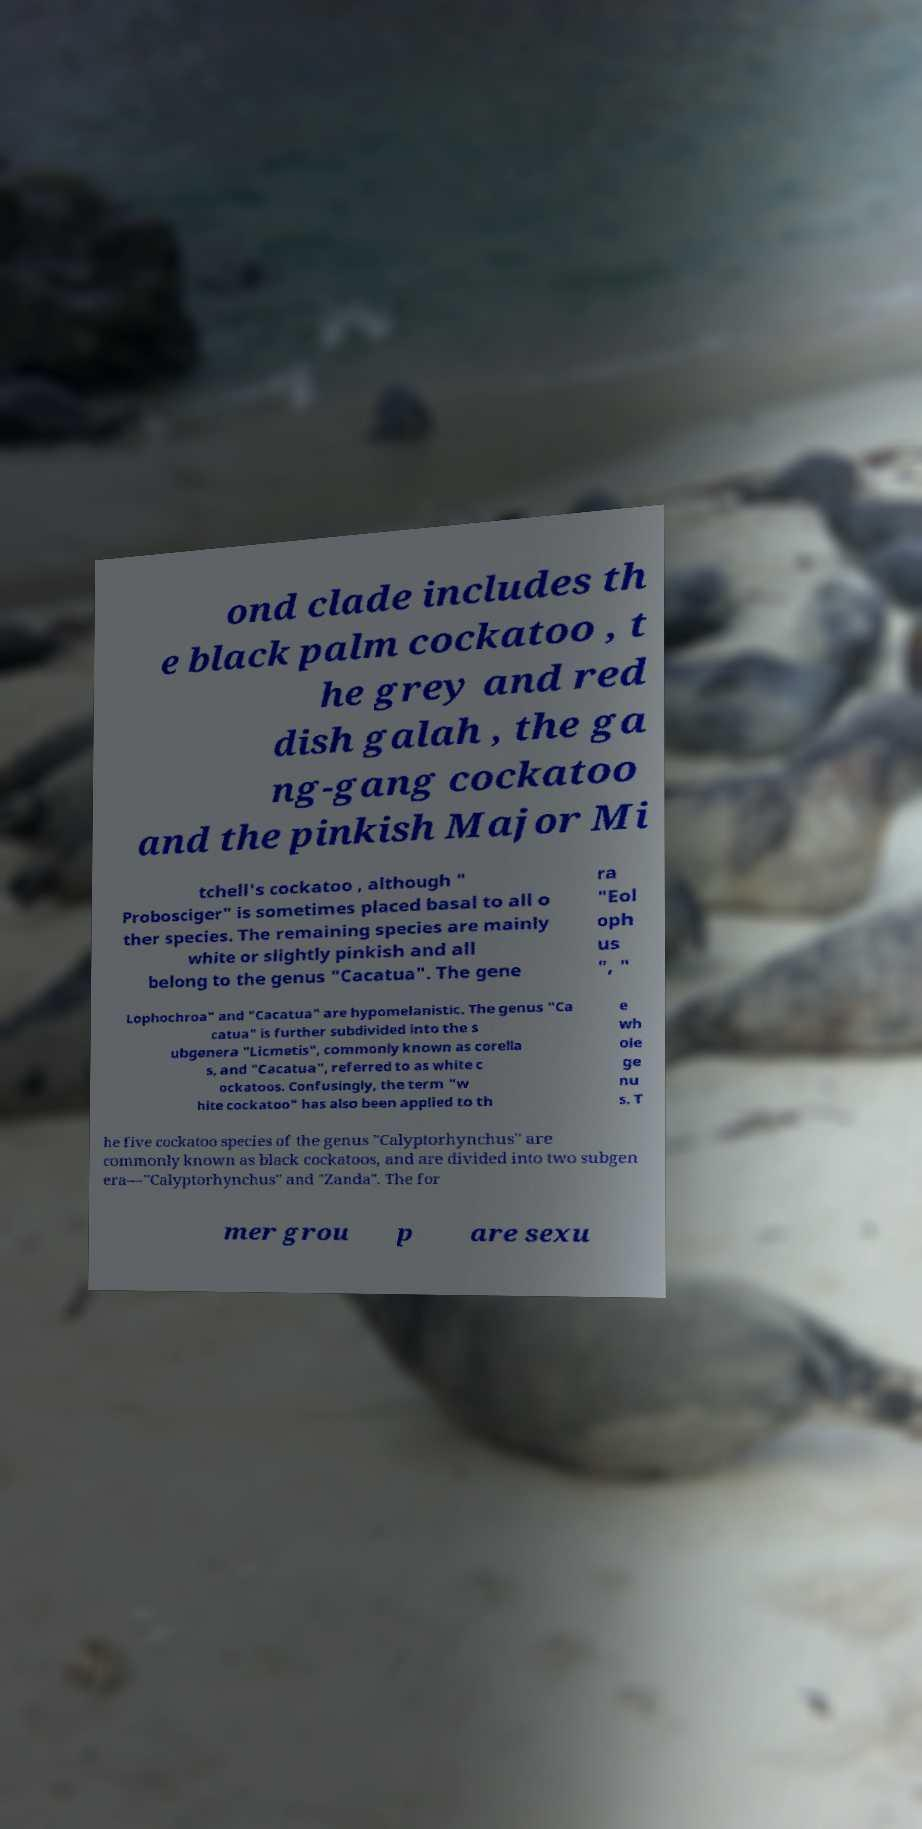What messages or text are displayed in this image? I need them in a readable, typed format. ond clade includes th e black palm cockatoo , t he grey and red dish galah , the ga ng-gang cockatoo and the pinkish Major Mi tchell's cockatoo , although " Probosciger" is sometimes placed basal to all o ther species. The remaining species are mainly white or slightly pinkish and all belong to the genus "Cacatua". The gene ra "Eol oph us ", " Lophochroa" and "Cacatua" are hypomelanistic. The genus "Ca catua" is further subdivided into the s ubgenera "Licmetis", commonly known as corella s, and "Cacatua", referred to as white c ockatoos. Confusingly, the term "w hite cockatoo" has also been applied to th e wh ole ge nu s. T he five cockatoo species of the genus "Calyptorhynchus" are commonly known as black cockatoos, and are divided into two subgen era—"Calyptorhynchus" and "Zanda". The for mer grou p are sexu 